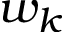Convert formula to latex. <formula><loc_0><loc_0><loc_500><loc_500>w _ { k }</formula> 